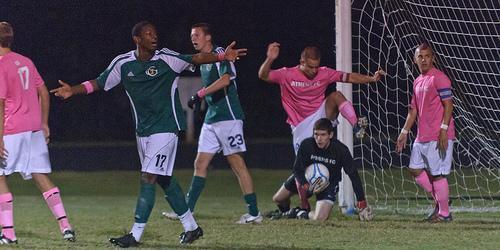How many players are there?
Give a very brief answer. 6. 